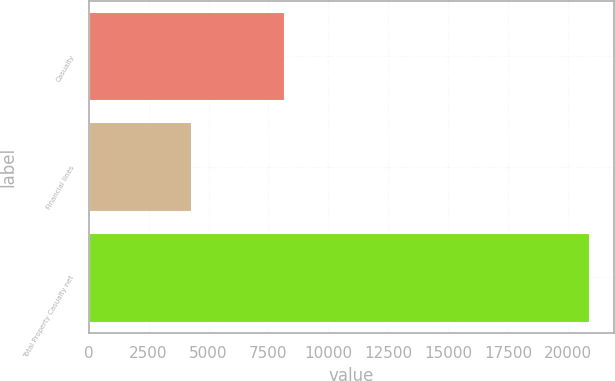<chart> <loc_0><loc_0><loc_500><loc_500><bar_chart><fcel>Casualty<fcel>Financial lines<fcel>Total Property Casualty net<nl><fcel>8154<fcel>4271<fcel>20880<nl></chart> 